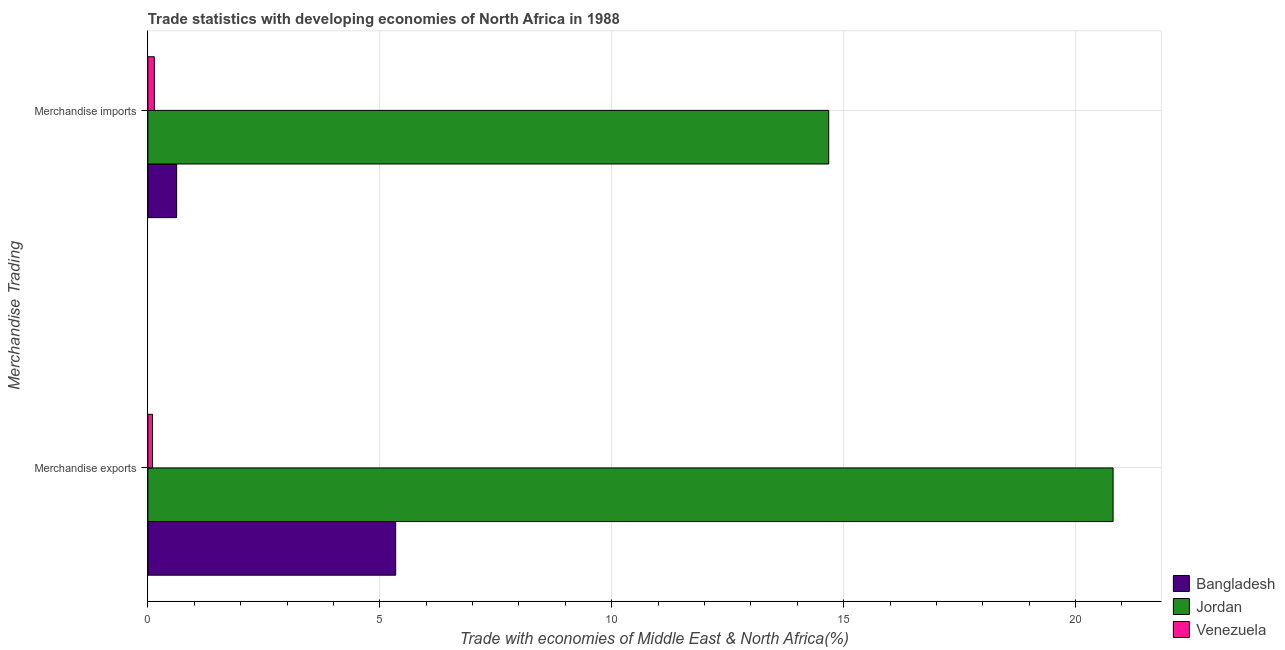How many groups of bars are there?
Give a very brief answer. 2. Are the number of bars per tick equal to the number of legend labels?
Your answer should be compact. Yes. Are the number of bars on each tick of the Y-axis equal?
Your answer should be very brief. Yes. How many bars are there on the 1st tick from the top?
Your answer should be compact. 3. What is the merchandise exports in Venezuela?
Give a very brief answer. 0.1. Across all countries, what is the maximum merchandise exports?
Provide a succinct answer. 20.81. Across all countries, what is the minimum merchandise exports?
Make the answer very short. 0.1. In which country was the merchandise exports maximum?
Your answer should be very brief. Jordan. In which country was the merchandise exports minimum?
Your response must be concise. Venezuela. What is the total merchandise exports in the graph?
Provide a succinct answer. 26.25. What is the difference between the merchandise exports in Venezuela and that in Bangladesh?
Your answer should be compact. -5.24. What is the difference between the merchandise exports in Venezuela and the merchandise imports in Jordan?
Offer a terse response. -14.58. What is the average merchandise exports per country?
Your answer should be compact. 8.75. What is the difference between the merchandise imports and merchandise exports in Venezuela?
Keep it short and to the point. 0.04. In how many countries, is the merchandise exports greater than 3 %?
Provide a succinct answer. 2. What is the ratio of the merchandise exports in Venezuela to that in Jordan?
Your response must be concise. 0. What does the 1st bar from the top in Merchandise imports represents?
Offer a terse response. Venezuela. What does the 1st bar from the bottom in Merchandise exports represents?
Ensure brevity in your answer.  Bangladesh. How many bars are there?
Offer a very short reply. 6. Are all the bars in the graph horizontal?
Keep it short and to the point. Yes. How many countries are there in the graph?
Keep it short and to the point. 3. What is the difference between two consecutive major ticks on the X-axis?
Give a very brief answer. 5. Are the values on the major ticks of X-axis written in scientific E-notation?
Give a very brief answer. No. What is the title of the graph?
Keep it short and to the point. Trade statistics with developing economies of North Africa in 1988. Does "New Caledonia" appear as one of the legend labels in the graph?
Your response must be concise. No. What is the label or title of the X-axis?
Provide a short and direct response. Trade with economies of Middle East & North Africa(%). What is the label or title of the Y-axis?
Offer a terse response. Merchandise Trading. What is the Trade with economies of Middle East & North Africa(%) in Bangladesh in Merchandise exports?
Make the answer very short. 5.34. What is the Trade with economies of Middle East & North Africa(%) in Jordan in Merchandise exports?
Provide a succinct answer. 20.81. What is the Trade with economies of Middle East & North Africa(%) of Venezuela in Merchandise exports?
Offer a very short reply. 0.1. What is the Trade with economies of Middle East & North Africa(%) in Bangladesh in Merchandise imports?
Provide a succinct answer. 0.62. What is the Trade with economies of Middle East & North Africa(%) of Jordan in Merchandise imports?
Ensure brevity in your answer.  14.68. What is the Trade with economies of Middle East & North Africa(%) of Venezuela in Merchandise imports?
Provide a short and direct response. 0.14. Across all Merchandise Trading, what is the maximum Trade with economies of Middle East & North Africa(%) in Bangladesh?
Give a very brief answer. 5.34. Across all Merchandise Trading, what is the maximum Trade with economies of Middle East & North Africa(%) of Jordan?
Your answer should be very brief. 20.81. Across all Merchandise Trading, what is the maximum Trade with economies of Middle East & North Africa(%) in Venezuela?
Give a very brief answer. 0.14. Across all Merchandise Trading, what is the minimum Trade with economies of Middle East & North Africa(%) of Bangladesh?
Provide a succinct answer. 0.62. Across all Merchandise Trading, what is the minimum Trade with economies of Middle East & North Africa(%) of Jordan?
Keep it short and to the point. 14.68. Across all Merchandise Trading, what is the minimum Trade with economies of Middle East & North Africa(%) in Venezuela?
Offer a very short reply. 0.1. What is the total Trade with economies of Middle East & North Africa(%) in Bangladesh in the graph?
Your answer should be very brief. 5.96. What is the total Trade with economies of Middle East & North Africa(%) of Jordan in the graph?
Offer a very short reply. 35.49. What is the total Trade with economies of Middle East & North Africa(%) in Venezuela in the graph?
Your answer should be compact. 0.24. What is the difference between the Trade with economies of Middle East & North Africa(%) of Bangladesh in Merchandise exports and that in Merchandise imports?
Your answer should be very brief. 4.72. What is the difference between the Trade with economies of Middle East & North Africa(%) of Jordan in Merchandise exports and that in Merchandise imports?
Ensure brevity in your answer.  6.13. What is the difference between the Trade with economies of Middle East & North Africa(%) of Venezuela in Merchandise exports and that in Merchandise imports?
Your response must be concise. -0.04. What is the difference between the Trade with economies of Middle East & North Africa(%) in Bangladesh in Merchandise exports and the Trade with economies of Middle East & North Africa(%) in Jordan in Merchandise imports?
Give a very brief answer. -9.34. What is the difference between the Trade with economies of Middle East & North Africa(%) in Bangladesh in Merchandise exports and the Trade with economies of Middle East & North Africa(%) in Venezuela in Merchandise imports?
Give a very brief answer. 5.2. What is the difference between the Trade with economies of Middle East & North Africa(%) of Jordan in Merchandise exports and the Trade with economies of Middle East & North Africa(%) of Venezuela in Merchandise imports?
Offer a terse response. 20.67. What is the average Trade with economies of Middle East & North Africa(%) in Bangladesh per Merchandise Trading?
Provide a succinct answer. 2.98. What is the average Trade with economies of Middle East & North Africa(%) in Jordan per Merchandise Trading?
Your answer should be very brief. 17.74. What is the average Trade with economies of Middle East & North Africa(%) of Venezuela per Merchandise Trading?
Keep it short and to the point. 0.12. What is the difference between the Trade with economies of Middle East & North Africa(%) of Bangladesh and Trade with economies of Middle East & North Africa(%) of Jordan in Merchandise exports?
Offer a terse response. -15.47. What is the difference between the Trade with economies of Middle East & North Africa(%) in Bangladesh and Trade with economies of Middle East & North Africa(%) in Venezuela in Merchandise exports?
Provide a short and direct response. 5.24. What is the difference between the Trade with economies of Middle East & North Africa(%) of Jordan and Trade with economies of Middle East & North Africa(%) of Venezuela in Merchandise exports?
Offer a very short reply. 20.71. What is the difference between the Trade with economies of Middle East & North Africa(%) of Bangladesh and Trade with economies of Middle East & North Africa(%) of Jordan in Merchandise imports?
Keep it short and to the point. -14.06. What is the difference between the Trade with economies of Middle East & North Africa(%) of Bangladesh and Trade with economies of Middle East & North Africa(%) of Venezuela in Merchandise imports?
Provide a succinct answer. 0.48. What is the difference between the Trade with economies of Middle East & North Africa(%) in Jordan and Trade with economies of Middle East & North Africa(%) in Venezuela in Merchandise imports?
Your answer should be very brief. 14.54. What is the ratio of the Trade with economies of Middle East & North Africa(%) in Bangladesh in Merchandise exports to that in Merchandise imports?
Offer a terse response. 8.62. What is the ratio of the Trade with economies of Middle East & North Africa(%) in Jordan in Merchandise exports to that in Merchandise imports?
Offer a very short reply. 1.42. What is the ratio of the Trade with economies of Middle East & North Africa(%) of Venezuela in Merchandise exports to that in Merchandise imports?
Offer a very short reply. 0.71. What is the difference between the highest and the second highest Trade with economies of Middle East & North Africa(%) of Bangladesh?
Give a very brief answer. 4.72. What is the difference between the highest and the second highest Trade with economies of Middle East & North Africa(%) of Jordan?
Provide a succinct answer. 6.13. What is the difference between the highest and the second highest Trade with economies of Middle East & North Africa(%) of Venezuela?
Offer a terse response. 0.04. What is the difference between the highest and the lowest Trade with economies of Middle East & North Africa(%) of Bangladesh?
Provide a succinct answer. 4.72. What is the difference between the highest and the lowest Trade with economies of Middle East & North Africa(%) of Jordan?
Provide a short and direct response. 6.13. What is the difference between the highest and the lowest Trade with economies of Middle East & North Africa(%) in Venezuela?
Your answer should be very brief. 0.04. 